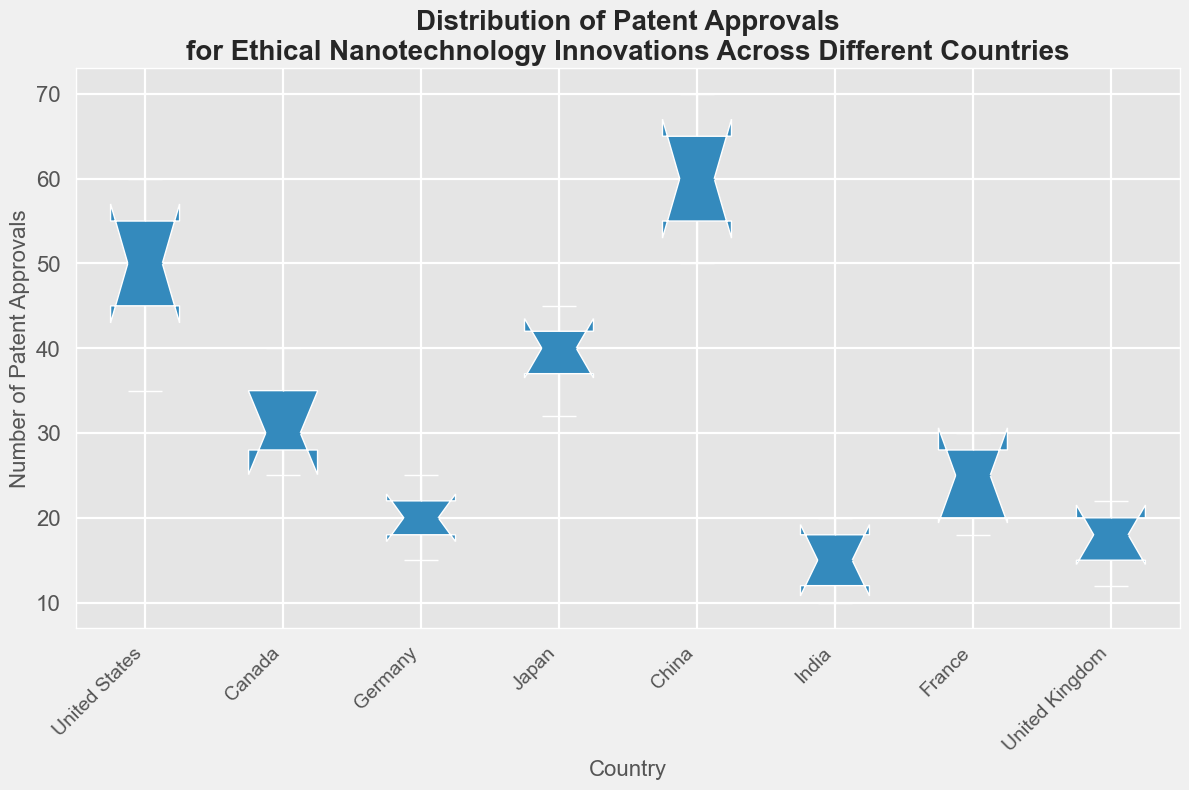Which country has the highest median number of patent approvals? Look at the median lines (the notch lines) in each box plot. The median for China is the highest.
Answer: China Which country has the smallest range of patent approvals? The range is the difference between the maximum and minimum values in each box plot. Germany has the smallest range as its box plot is the shortest in height.
Answer: Germany Which countries have a median number of patent approvals of around 20? Identify the median lines (notch lines) that are closest to the value 20. Germany, India, and the United Kingdom have medians close to 20.
Answer: Germany, India, United Kingdom What is the interquartile range (IQR) of patent approvals for Japan? The IQR is the height of the box (distance between the top and bottom edges). For Japan, this is from 37 (25th percentile) to 42 (75th percentile), so the IQR is 42 - 37 = 5.
Answer: 5 Compare the variability in patent approvals between the United States and Canada. Which country has more consistent (less variable) number of approvals? Look at the heights of the box plots; a shorter box indicates less variability. Canada's box plot is shorter than that of the United States, indicating more consistent values.
Answer: Canada Which country shows the greatest overall spread in patent approvals? The spread is the distance from the lowest to the highest point in the box plot. China has the greatest overall spread.
Answer: China How does France's median number of patent approvals compare to that of Canada? Compare the median lines (notch lines). France's median is below Canada's.
Answer: France's median is lower than Canada's What is the difference between the highest value of patent approvals for China and Germany? The highest value for China is 70, and for Germany, it is 25. The difference is 70 - 25 = 45.
Answer: 45 What color is associated with the box plot for China? Identify the color of the China box plot (look for the country label and corresponding color). The color for China is pink.
Answer: Pink 